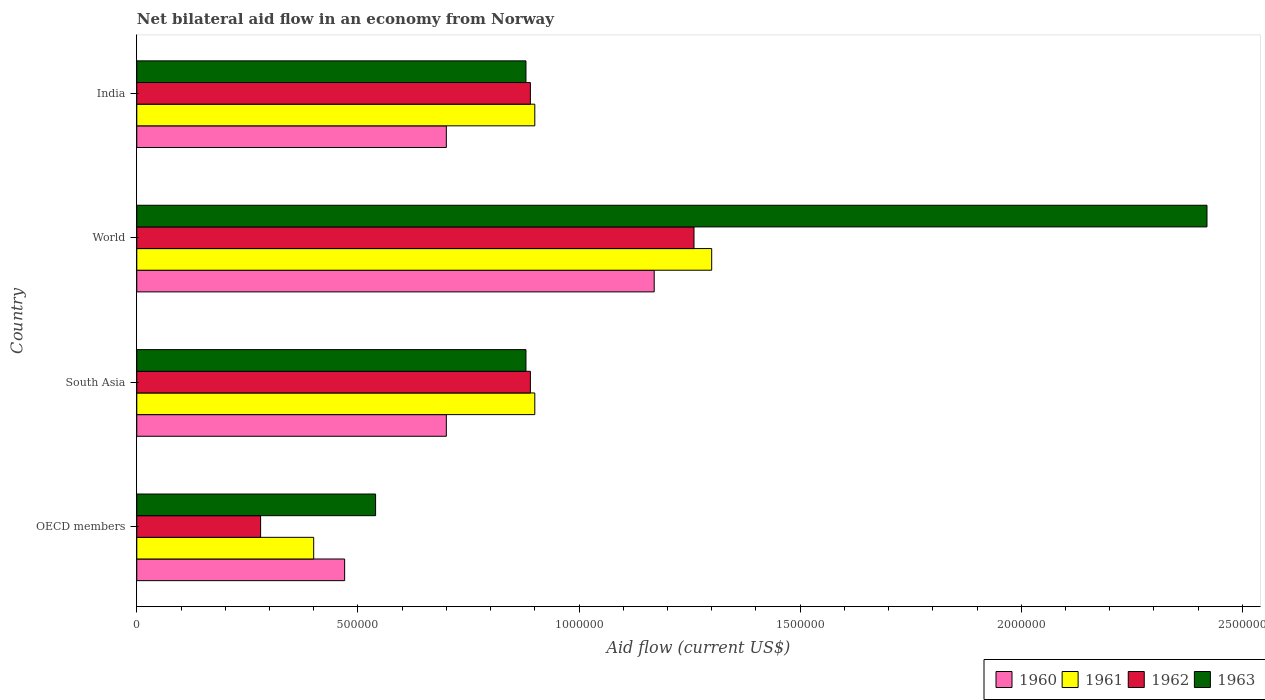How many groups of bars are there?
Offer a terse response. 4. How many bars are there on the 1st tick from the top?
Ensure brevity in your answer.  4. How many bars are there on the 3rd tick from the bottom?
Your response must be concise. 4. What is the label of the 3rd group of bars from the top?
Your answer should be compact. South Asia. What is the net bilateral aid flow in 1963 in South Asia?
Keep it short and to the point. 8.80e+05. Across all countries, what is the maximum net bilateral aid flow in 1963?
Offer a very short reply. 2.42e+06. Across all countries, what is the minimum net bilateral aid flow in 1963?
Your answer should be compact. 5.40e+05. In which country was the net bilateral aid flow in 1960 minimum?
Your answer should be very brief. OECD members. What is the total net bilateral aid flow in 1963 in the graph?
Provide a succinct answer. 4.72e+06. What is the difference between the net bilateral aid flow in 1962 in India and that in World?
Offer a terse response. -3.70e+05. What is the difference between the net bilateral aid flow in 1960 in South Asia and the net bilateral aid flow in 1963 in OECD members?
Ensure brevity in your answer.  1.60e+05. What is the average net bilateral aid flow in 1960 per country?
Your answer should be very brief. 7.60e+05. What is the difference between the net bilateral aid flow in 1961 and net bilateral aid flow in 1962 in India?
Give a very brief answer. 10000. In how many countries, is the net bilateral aid flow in 1960 greater than 600000 US$?
Ensure brevity in your answer.  3. What is the ratio of the net bilateral aid flow in 1963 in India to that in World?
Your response must be concise. 0.36. Is the difference between the net bilateral aid flow in 1961 in India and OECD members greater than the difference between the net bilateral aid flow in 1962 in India and OECD members?
Offer a terse response. No. What does the 2nd bar from the bottom in South Asia represents?
Offer a terse response. 1961. How many bars are there?
Provide a succinct answer. 16. Are all the bars in the graph horizontal?
Provide a short and direct response. Yes. How many countries are there in the graph?
Give a very brief answer. 4. Does the graph contain any zero values?
Ensure brevity in your answer.  No. Where does the legend appear in the graph?
Keep it short and to the point. Bottom right. How many legend labels are there?
Make the answer very short. 4. What is the title of the graph?
Give a very brief answer. Net bilateral aid flow in an economy from Norway. What is the Aid flow (current US$) in 1961 in OECD members?
Offer a terse response. 4.00e+05. What is the Aid flow (current US$) of 1962 in OECD members?
Provide a short and direct response. 2.80e+05. What is the Aid flow (current US$) of 1963 in OECD members?
Your answer should be very brief. 5.40e+05. What is the Aid flow (current US$) of 1960 in South Asia?
Offer a terse response. 7.00e+05. What is the Aid flow (current US$) in 1962 in South Asia?
Your response must be concise. 8.90e+05. What is the Aid flow (current US$) of 1963 in South Asia?
Offer a very short reply. 8.80e+05. What is the Aid flow (current US$) in 1960 in World?
Your answer should be compact. 1.17e+06. What is the Aid flow (current US$) in 1961 in World?
Provide a short and direct response. 1.30e+06. What is the Aid flow (current US$) in 1962 in World?
Keep it short and to the point. 1.26e+06. What is the Aid flow (current US$) in 1963 in World?
Your answer should be compact. 2.42e+06. What is the Aid flow (current US$) in 1961 in India?
Keep it short and to the point. 9.00e+05. What is the Aid flow (current US$) of 1962 in India?
Provide a short and direct response. 8.90e+05. What is the Aid flow (current US$) of 1963 in India?
Your response must be concise. 8.80e+05. Across all countries, what is the maximum Aid flow (current US$) in 1960?
Your answer should be compact. 1.17e+06. Across all countries, what is the maximum Aid flow (current US$) in 1961?
Provide a succinct answer. 1.30e+06. Across all countries, what is the maximum Aid flow (current US$) in 1962?
Ensure brevity in your answer.  1.26e+06. Across all countries, what is the maximum Aid flow (current US$) in 1963?
Your answer should be very brief. 2.42e+06. Across all countries, what is the minimum Aid flow (current US$) in 1962?
Give a very brief answer. 2.80e+05. Across all countries, what is the minimum Aid flow (current US$) in 1963?
Your answer should be very brief. 5.40e+05. What is the total Aid flow (current US$) in 1960 in the graph?
Offer a terse response. 3.04e+06. What is the total Aid flow (current US$) in 1961 in the graph?
Provide a short and direct response. 3.50e+06. What is the total Aid flow (current US$) of 1962 in the graph?
Offer a very short reply. 3.32e+06. What is the total Aid flow (current US$) of 1963 in the graph?
Your answer should be very brief. 4.72e+06. What is the difference between the Aid flow (current US$) of 1960 in OECD members and that in South Asia?
Make the answer very short. -2.30e+05. What is the difference between the Aid flow (current US$) of 1961 in OECD members and that in South Asia?
Your answer should be compact. -5.00e+05. What is the difference between the Aid flow (current US$) in 1962 in OECD members and that in South Asia?
Your answer should be compact. -6.10e+05. What is the difference between the Aid flow (current US$) in 1963 in OECD members and that in South Asia?
Provide a succinct answer. -3.40e+05. What is the difference between the Aid flow (current US$) of 1960 in OECD members and that in World?
Offer a terse response. -7.00e+05. What is the difference between the Aid flow (current US$) of 1961 in OECD members and that in World?
Make the answer very short. -9.00e+05. What is the difference between the Aid flow (current US$) in 1962 in OECD members and that in World?
Provide a succinct answer. -9.80e+05. What is the difference between the Aid flow (current US$) in 1963 in OECD members and that in World?
Provide a short and direct response. -1.88e+06. What is the difference between the Aid flow (current US$) of 1960 in OECD members and that in India?
Offer a terse response. -2.30e+05. What is the difference between the Aid flow (current US$) in 1961 in OECD members and that in India?
Keep it short and to the point. -5.00e+05. What is the difference between the Aid flow (current US$) of 1962 in OECD members and that in India?
Provide a short and direct response. -6.10e+05. What is the difference between the Aid flow (current US$) of 1963 in OECD members and that in India?
Give a very brief answer. -3.40e+05. What is the difference between the Aid flow (current US$) of 1960 in South Asia and that in World?
Make the answer very short. -4.70e+05. What is the difference between the Aid flow (current US$) in 1961 in South Asia and that in World?
Your answer should be compact. -4.00e+05. What is the difference between the Aid flow (current US$) of 1962 in South Asia and that in World?
Provide a short and direct response. -3.70e+05. What is the difference between the Aid flow (current US$) in 1963 in South Asia and that in World?
Your answer should be very brief. -1.54e+06. What is the difference between the Aid flow (current US$) of 1960 in South Asia and that in India?
Ensure brevity in your answer.  0. What is the difference between the Aid flow (current US$) in 1961 in South Asia and that in India?
Make the answer very short. 0. What is the difference between the Aid flow (current US$) in 1963 in South Asia and that in India?
Provide a short and direct response. 0. What is the difference between the Aid flow (current US$) in 1960 in World and that in India?
Make the answer very short. 4.70e+05. What is the difference between the Aid flow (current US$) of 1962 in World and that in India?
Offer a terse response. 3.70e+05. What is the difference between the Aid flow (current US$) of 1963 in World and that in India?
Make the answer very short. 1.54e+06. What is the difference between the Aid flow (current US$) of 1960 in OECD members and the Aid flow (current US$) of 1961 in South Asia?
Provide a succinct answer. -4.30e+05. What is the difference between the Aid flow (current US$) of 1960 in OECD members and the Aid flow (current US$) of 1962 in South Asia?
Offer a terse response. -4.20e+05. What is the difference between the Aid flow (current US$) of 1960 in OECD members and the Aid flow (current US$) of 1963 in South Asia?
Ensure brevity in your answer.  -4.10e+05. What is the difference between the Aid flow (current US$) of 1961 in OECD members and the Aid flow (current US$) of 1962 in South Asia?
Your answer should be compact. -4.90e+05. What is the difference between the Aid flow (current US$) of 1961 in OECD members and the Aid flow (current US$) of 1963 in South Asia?
Offer a terse response. -4.80e+05. What is the difference between the Aid flow (current US$) of 1962 in OECD members and the Aid flow (current US$) of 1963 in South Asia?
Offer a very short reply. -6.00e+05. What is the difference between the Aid flow (current US$) in 1960 in OECD members and the Aid flow (current US$) in 1961 in World?
Ensure brevity in your answer.  -8.30e+05. What is the difference between the Aid flow (current US$) in 1960 in OECD members and the Aid flow (current US$) in 1962 in World?
Offer a very short reply. -7.90e+05. What is the difference between the Aid flow (current US$) in 1960 in OECD members and the Aid flow (current US$) in 1963 in World?
Ensure brevity in your answer.  -1.95e+06. What is the difference between the Aid flow (current US$) in 1961 in OECD members and the Aid flow (current US$) in 1962 in World?
Your answer should be compact. -8.60e+05. What is the difference between the Aid flow (current US$) of 1961 in OECD members and the Aid flow (current US$) of 1963 in World?
Keep it short and to the point. -2.02e+06. What is the difference between the Aid flow (current US$) of 1962 in OECD members and the Aid flow (current US$) of 1963 in World?
Your answer should be very brief. -2.14e+06. What is the difference between the Aid flow (current US$) of 1960 in OECD members and the Aid flow (current US$) of 1961 in India?
Provide a short and direct response. -4.30e+05. What is the difference between the Aid flow (current US$) of 1960 in OECD members and the Aid flow (current US$) of 1962 in India?
Your answer should be very brief. -4.20e+05. What is the difference between the Aid flow (current US$) of 1960 in OECD members and the Aid flow (current US$) of 1963 in India?
Your answer should be very brief. -4.10e+05. What is the difference between the Aid flow (current US$) of 1961 in OECD members and the Aid flow (current US$) of 1962 in India?
Make the answer very short. -4.90e+05. What is the difference between the Aid flow (current US$) in 1961 in OECD members and the Aid flow (current US$) in 1963 in India?
Your response must be concise. -4.80e+05. What is the difference between the Aid flow (current US$) of 1962 in OECD members and the Aid flow (current US$) of 1963 in India?
Your answer should be compact. -6.00e+05. What is the difference between the Aid flow (current US$) in 1960 in South Asia and the Aid flow (current US$) in 1961 in World?
Your response must be concise. -6.00e+05. What is the difference between the Aid flow (current US$) in 1960 in South Asia and the Aid flow (current US$) in 1962 in World?
Keep it short and to the point. -5.60e+05. What is the difference between the Aid flow (current US$) of 1960 in South Asia and the Aid flow (current US$) of 1963 in World?
Your response must be concise. -1.72e+06. What is the difference between the Aid flow (current US$) of 1961 in South Asia and the Aid flow (current US$) of 1962 in World?
Offer a terse response. -3.60e+05. What is the difference between the Aid flow (current US$) in 1961 in South Asia and the Aid flow (current US$) in 1963 in World?
Your response must be concise. -1.52e+06. What is the difference between the Aid flow (current US$) in 1962 in South Asia and the Aid flow (current US$) in 1963 in World?
Ensure brevity in your answer.  -1.53e+06. What is the difference between the Aid flow (current US$) of 1962 in South Asia and the Aid flow (current US$) of 1963 in India?
Provide a succinct answer. 10000. What is the difference between the Aid flow (current US$) in 1960 in World and the Aid flow (current US$) in 1962 in India?
Ensure brevity in your answer.  2.80e+05. What is the difference between the Aid flow (current US$) in 1960 in World and the Aid flow (current US$) in 1963 in India?
Your answer should be compact. 2.90e+05. What is the difference between the Aid flow (current US$) of 1961 in World and the Aid flow (current US$) of 1962 in India?
Ensure brevity in your answer.  4.10e+05. What is the average Aid flow (current US$) in 1960 per country?
Provide a succinct answer. 7.60e+05. What is the average Aid flow (current US$) in 1961 per country?
Provide a succinct answer. 8.75e+05. What is the average Aid flow (current US$) in 1962 per country?
Provide a short and direct response. 8.30e+05. What is the average Aid flow (current US$) in 1963 per country?
Offer a very short reply. 1.18e+06. What is the difference between the Aid flow (current US$) of 1960 and Aid flow (current US$) of 1961 in OECD members?
Your answer should be very brief. 7.00e+04. What is the difference between the Aid flow (current US$) in 1960 and Aid flow (current US$) in 1962 in OECD members?
Offer a very short reply. 1.90e+05. What is the difference between the Aid flow (current US$) in 1961 and Aid flow (current US$) in 1963 in OECD members?
Offer a very short reply. -1.40e+05. What is the difference between the Aid flow (current US$) in 1960 and Aid flow (current US$) in 1961 in World?
Offer a terse response. -1.30e+05. What is the difference between the Aid flow (current US$) of 1960 and Aid flow (current US$) of 1963 in World?
Make the answer very short. -1.25e+06. What is the difference between the Aid flow (current US$) in 1961 and Aid flow (current US$) in 1962 in World?
Offer a very short reply. 4.00e+04. What is the difference between the Aid flow (current US$) of 1961 and Aid flow (current US$) of 1963 in World?
Provide a succinct answer. -1.12e+06. What is the difference between the Aid flow (current US$) in 1962 and Aid flow (current US$) in 1963 in World?
Provide a short and direct response. -1.16e+06. What is the difference between the Aid flow (current US$) in 1960 and Aid flow (current US$) in 1961 in India?
Offer a very short reply. -2.00e+05. What is the difference between the Aid flow (current US$) in 1960 and Aid flow (current US$) in 1962 in India?
Provide a short and direct response. -1.90e+05. What is the difference between the Aid flow (current US$) in 1961 and Aid flow (current US$) in 1962 in India?
Make the answer very short. 10000. What is the difference between the Aid flow (current US$) of 1961 and Aid flow (current US$) of 1963 in India?
Your answer should be very brief. 2.00e+04. What is the ratio of the Aid flow (current US$) in 1960 in OECD members to that in South Asia?
Your response must be concise. 0.67. What is the ratio of the Aid flow (current US$) of 1961 in OECD members to that in South Asia?
Offer a very short reply. 0.44. What is the ratio of the Aid flow (current US$) of 1962 in OECD members to that in South Asia?
Offer a terse response. 0.31. What is the ratio of the Aid flow (current US$) of 1963 in OECD members to that in South Asia?
Your answer should be very brief. 0.61. What is the ratio of the Aid flow (current US$) in 1960 in OECD members to that in World?
Provide a short and direct response. 0.4. What is the ratio of the Aid flow (current US$) in 1961 in OECD members to that in World?
Your answer should be very brief. 0.31. What is the ratio of the Aid flow (current US$) in 1962 in OECD members to that in World?
Ensure brevity in your answer.  0.22. What is the ratio of the Aid flow (current US$) in 1963 in OECD members to that in World?
Your response must be concise. 0.22. What is the ratio of the Aid flow (current US$) in 1960 in OECD members to that in India?
Your response must be concise. 0.67. What is the ratio of the Aid flow (current US$) of 1961 in OECD members to that in India?
Keep it short and to the point. 0.44. What is the ratio of the Aid flow (current US$) of 1962 in OECD members to that in India?
Give a very brief answer. 0.31. What is the ratio of the Aid flow (current US$) of 1963 in OECD members to that in India?
Your response must be concise. 0.61. What is the ratio of the Aid flow (current US$) in 1960 in South Asia to that in World?
Ensure brevity in your answer.  0.6. What is the ratio of the Aid flow (current US$) in 1961 in South Asia to that in World?
Your answer should be compact. 0.69. What is the ratio of the Aid flow (current US$) of 1962 in South Asia to that in World?
Provide a short and direct response. 0.71. What is the ratio of the Aid flow (current US$) of 1963 in South Asia to that in World?
Provide a succinct answer. 0.36. What is the ratio of the Aid flow (current US$) in 1960 in South Asia to that in India?
Your answer should be compact. 1. What is the ratio of the Aid flow (current US$) of 1962 in South Asia to that in India?
Your response must be concise. 1. What is the ratio of the Aid flow (current US$) of 1963 in South Asia to that in India?
Make the answer very short. 1. What is the ratio of the Aid flow (current US$) in 1960 in World to that in India?
Your answer should be very brief. 1.67. What is the ratio of the Aid flow (current US$) in 1961 in World to that in India?
Make the answer very short. 1.44. What is the ratio of the Aid flow (current US$) of 1962 in World to that in India?
Offer a terse response. 1.42. What is the ratio of the Aid flow (current US$) in 1963 in World to that in India?
Your response must be concise. 2.75. What is the difference between the highest and the second highest Aid flow (current US$) of 1961?
Your response must be concise. 4.00e+05. What is the difference between the highest and the second highest Aid flow (current US$) of 1963?
Make the answer very short. 1.54e+06. What is the difference between the highest and the lowest Aid flow (current US$) of 1960?
Keep it short and to the point. 7.00e+05. What is the difference between the highest and the lowest Aid flow (current US$) in 1962?
Make the answer very short. 9.80e+05. What is the difference between the highest and the lowest Aid flow (current US$) in 1963?
Provide a short and direct response. 1.88e+06. 